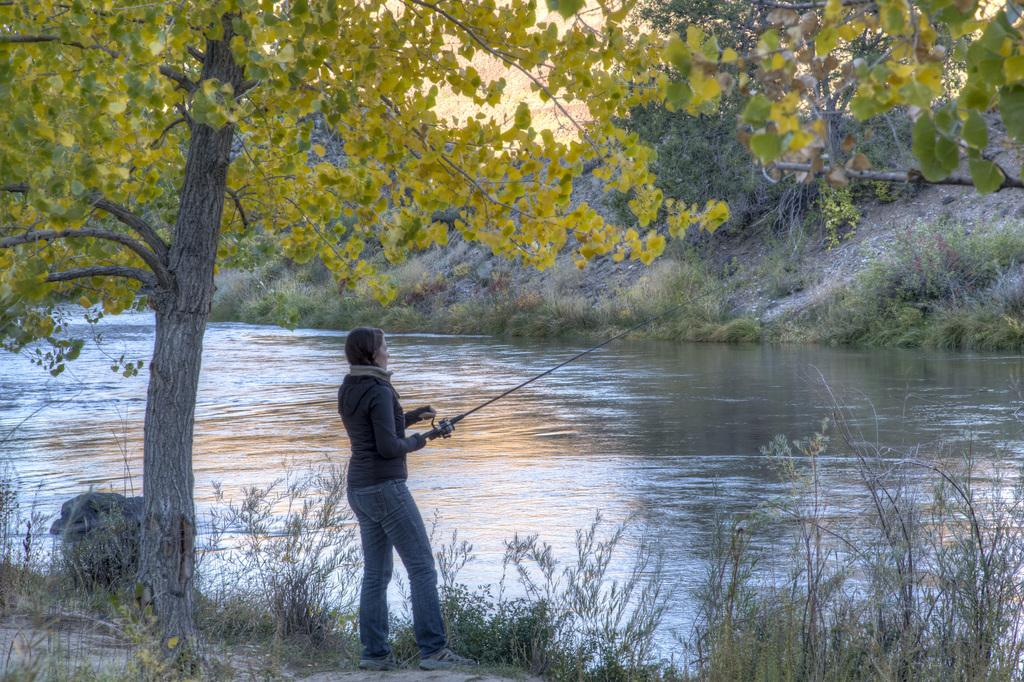What is the main subject of the image? There is a woman in the image. What is the woman holding in the image? The woman is holding a stick. What is the woman's posture in the image? The woman is standing. What type of vegetation can be seen at the bottom of the image? There are plants and grass at the bottom of the image. What body of water is present in the image? There is a river in the middle of the image. How many trees are visible in the image? There are so many trees in the image. What song is the woman singing in the image? There is no indication in the image that the woman is singing a song. How is the distribution of cars in the image? There are no cars present in the image. 